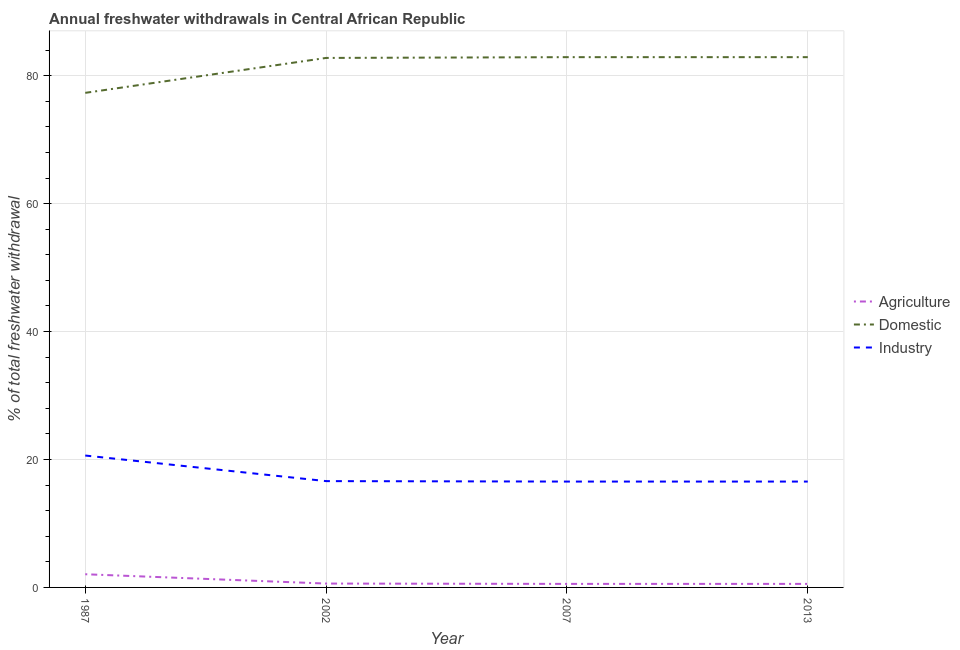How many different coloured lines are there?
Give a very brief answer. 3. Is the number of lines equal to the number of legend labels?
Your answer should be compact. Yes. What is the percentage of freshwater withdrawal for agriculture in 1987?
Your response must be concise. 2.06. Across all years, what is the maximum percentage of freshwater withdrawal for agriculture?
Make the answer very short. 2.06. Across all years, what is the minimum percentage of freshwater withdrawal for agriculture?
Make the answer very short. 0.55. What is the total percentage of freshwater withdrawal for domestic purposes in the graph?
Provide a succinct answer. 325.9. What is the difference between the percentage of freshwater withdrawal for industry in 1987 and that in 2002?
Offer a very short reply. 4. What is the difference between the percentage of freshwater withdrawal for industry in 2007 and the percentage of freshwater withdrawal for domestic purposes in 2002?
Keep it short and to the point. -66.23. What is the average percentage of freshwater withdrawal for industry per year?
Ensure brevity in your answer.  17.59. In the year 2002, what is the difference between the percentage of freshwater withdrawal for agriculture and percentage of freshwater withdrawal for industry?
Offer a terse response. -16.02. What is the ratio of the percentage of freshwater withdrawal for domestic purposes in 1987 to that in 2002?
Provide a short and direct response. 0.93. What is the difference between the highest and the second highest percentage of freshwater withdrawal for domestic purposes?
Provide a short and direct response. 0. What is the difference between the highest and the lowest percentage of freshwater withdrawal for agriculture?
Keep it short and to the point. 1.51. In how many years, is the percentage of freshwater withdrawal for domestic purposes greater than the average percentage of freshwater withdrawal for domestic purposes taken over all years?
Your response must be concise. 3. Does the percentage of freshwater withdrawal for domestic purposes monotonically increase over the years?
Your answer should be compact. No. Is the percentage of freshwater withdrawal for industry strictly less than the percentage of freshwater withdrawal for agriculture over the years?
Your answer should be compact. No. How many lines are there?
Your answer should be very brief. 3. How many years are there in the graph?
Your response must be concise. 4. Does the graph contain grids?
Offer a very short reply. Yes. Where does the legend appear in the graph?
Keep it short and to the point. Center right. How are the legend labels stacked?
Ensure brevity in your answer.  Vertical. What is the title of the graph?
Give a very brief answer. Annual freshwater withdrawals in Central African Republic. What is the label or title of the X-axis?
Give a very brief answer. Year. What is the label or title of the Y-axis?
Ensure brevity in your answer.  % of total freshwater withdrawal. What is the % of total freshwater withdrawal in Agriculture in 1987?
Ensure brevity in your answer.  2.06. What is the % of total freshwater withdrawal of Domestic in 1987?
Give a very brief answer. 77.32. What is the % of total freshwater withdrawal of Industry in 1987?
Provide a short and direct response. 20.62. What is the % of total freshwater withdrawal of Agriculture in 2002?
Give a very brief answer. 0.6. What is the % of total freshwater withdrawal of Domestic in 2002?
Your answer should be compact. 82.78. What is the % of total freshwater withdrawal of Industry in 2002?
Offer a very short reply. 16.62. What is the % of total freshwater withdrawal in Agriculture in 2007?
Offer a terse response. 0.55. What is the % of total freshwater withdrawal in Domestic in 2007?
Give a very brief answer. 82.9. What is the % of total freshwater withdrawal in Industry in 2007?
Your answer should be very brief. 16.55. What is the % of total freshwater withdrawal of Agriculture in 2013?
Offer a terse response. 0.55. What is the % of total freshwater withdrawal in Domestic in 2013?
Provide a succinct answer. 82.9. What is the % of total freshwater withdrawal in Industry in 2013?
Your answer should be compact. 16.55. Across all years, what is the maximum % of total freshwater withdrawal in Agriculture?
Offer a terse response. 2.06. Across all years, what is the maximum % of total freshwater withdrawal of Domestic?
Provide a short and direct response. 82.9. Across all years, what is the maximum % of total freshwater withdrawal of Industry?
Offer a very short reply. 20.62. Across all years, what is the minimum % of total freshwater withdrawal in Agriculture?
Give a very brief answer. 0.55. Across all years, what is the minimum % of total freshwater withdrawal of Domestic?
Provide a short and direct response. 77.32. Across all years, what is the minimum % of total freshwater withdrawal in Industry?
Your answer should be compact. 16.55. What is the total % of total freshwater withdrawal in Agriculture in the graph?
Provide a short and direct response. 3.77. What is the total % of total freshwater withdrawal of Domestic in the graph?
Provide a succinct answer. 325.9. What is the total % of total freshwater withdrawal of Industry in the graph?
Offer a very short reply. 70.34. What is the difference between the % of total freshwater withdrawal in Agriculture in 1987 and that in 2002?
Give a very brief answer. 1.46. What is the difference between the % of total freshwater withdrawal in Domestic in 1987 and that in 2002?
Your answer should be compact. -5.46. What is the difference between the % of total freshwater withdrawal of Industry in 1987 and that in 2002?
Make the answer very short. 4. What is the difference between the % of total freshwater withdrawal of Agriculture in 1987 and that in 2007?
Provide a succinct answer. 1.51. What is the difference between the % of total freshwater withdrawal in Domestic in 1987 and that in 2007?
Give a very brief answer. -5.58. What is the difference between the % of total freshwater withdrawal in Industry in 1987 and that in 2007?
Your response must be concise. 4.07. What is the difference between the % of total freshwater withdrawal of Agriculture in 1987 and that in 2013?
Your answer should be very brief. 1.51. What is the difference between the % of total freshwater withdrawal of Domestic in 1987 and that in 2013?
Keep it short and to the point. -5.58. What is the difference between the % of total freshwater withdrawal of Industry in 1987 and that in 2013?
Make the answer very short. 4.07. What is the difference between the % of total freshwater withdrawal of Agriculture in 2002 and that in 2007?
Offer a terse response. 0.05. What is the difference between the % of total freshwater withdrawal in Domestic in 2002 and that in 2007?
Ensure brevity in your answer.  -0.12. What is the difference between the % of total freshwater withdrawal in Industry in 2002 and that in 2007?
Offer a very short reply. 0.07. What is the difference between the % of total freshwater withdrawal in Agriculture in 2002 and that in 2013?
Provide a succinct answer. 0.05. What is the difference between the % of total freshwater withdrawal of Domestic in 2002 and that in 2013?
Give a very brief answer. -0.12. What is the difference between the % of total freshwater withdrawal of Industry in 2002 and that in 2013?
Make the answer very short. 0.07. What is the difference between the % of total freshwater withdrawal of Agriculture in 1987 and the % of total freshwater withdrawal of Domestic in 2002?
Your answer should be very brief. -80.72. What is the difference between the % of total freshwater withdrawal in Agriculture in 1987 and the % of total freshwater withdrawal in Industry in 2002?
Ensure brevity in your answer.  -14.56. What is the difference between the % of total freshwater withdrawal in Domestic in 1987 and the % of total freshwater withdrawal in Industry in 2002?
Your response must be concise. 60.7. What is the difference between the % of total freshwater withdrawal of Agriculture in 1987 and the % of total freshwater withdrawal of Domestic in 2007?
Your answer should be very brief. -80.84. What is the difference between the % of total freshwater withdrawal of Agriculture in 1987 and the % of total freshwater withdrawal of Industry in 2007?
Your response must be concise. -14.49. What is the difference between the % of total freshwater withdrawal of Domestic in 1987 and the % of total freshwater withdrawal of Industry in 2007?
Keep it short and to the point. 60.77. What is the difference between the % of total freshwater withdrawal in Agriculture in 1987 and the % of total freshwater withdrawal in Domestic in 2013?
Ensure brevity in your answer.  -80.84. What is the difference between the % of total freshwater withdrawal in Agriculture in 1987 and the % of total freshwater withdrawal in Industry in 2013?
Keep it short and to the point. -14.49. What is the difference between the % of total freshwater withdrawal in Domestic in 1987 and the % of total freshwater withdrawal in Industry in 2013?
Your answer should be compact. 60.77. What is the difference between the % of total freshwater withdrawal of Agriculture in 2002 and the % of total freshwater withdrawal of Domestic in 2007?
Provide a short and direct response. -82.3. What is the difference between the % of total freshwater withdrawal of Agriculture in 2002 and the % of total freshwater withdrawal of Industry in 2007?
Provide a short and direct response. -15.95. What is the difference between the % of total freshwater withdrawal of Domestic in 2002 and the % of total freshwater withdrawal of Industry in 2007?
Ensure brevity in your answer.  66.23. What is the difference between the % of total freshwater withdrawal of Agriculture in 2002 and the % of total freshwater withdrawal of Domestic in 2013?
Your response must be concise. -82.3. What is the difference between the % of total freshwater withdrawal of Agriculture in 2002 and the % of total freshwater withdrawal of Industry in 2013?
Offer a very short reply. -15.95. What is the difference between the % of total freshwater withdrawal of Domestic in 2002 and the % of total freshwater withdrawal of Industry in 2013?
Offer a very short reply. 66.23. What is the difference between the % of total freshwater withdrawal of Agriculture in 2007 and the % of total freshwater withdrawal of Domestic in 2013?
Your answer should be very brief. -82.35. What is the difference between the % of total freshwater withdrawal in Agriculture in 2007 and the % of total freshwater withdrawal in Industry in 2013?
Your response must be concise. -16. What is the difference between the % of total freshwater withdrawal in Domestic in 2007 and the % of total freshwater withdrawal in Industry in 2013?
Your answer should be very brief. 66.35. What is the average % of total freshwater withdrawal in Agriculture per year?
Ensure brevity in your answer.  0.94. What is the average % of total freshwater withdrawal in Domestic per year?
Give a very brief answer. 81.47. What is the average % of total freshwater withdrawal of Industry per year?
Ensure brevity in your answer.  17.59. In the year 1987, what is the difference between the % of total freshwater withdrawal of Agriculture and % of total freshwater withdrawal of Domestic?
Offer a very short reply. -75.26. In the year 1987, what is the difference between the % of total freshwater withdrawal of Agriculture and % of total freshwater withdrawal of Industry?
Ensure brevity in your answer.  -18.56. In the year 1987, what is the difference between the % of total freshwater withdrawal of Domestic and % of total freshwater withdrawal of Industry?
Give a very brief answer. 56.7. In the year 2002, what is the difference between the % of total freshwater withdrawal of Agriculture and % of total freshwater withdrawal of Domestic?
Make the answer very short. -82.18. In the year 2002, what is the difference between the % of total freshwater withdrawal of Agriculture and % of total freshwater withdrawal of Industry?
Make the answer very short. -16.02. In the year 2002, what is the difference between the % of total freshwater withdrawal of Domestic and % of total freshwater withdrawal of Industry?
Your answer should be compact. 66.16. In the year 2007, what is the difference between the % of total freshwater withdrawal in Agriculture and % of total freshwater withdrawal in Domestic?
Provide a succinct answer. -82.35. In the year 2007, what is the difference between the % of total freshwater withdrawal of Agriculture and % of total freshwater withdrawal of Industry?
Make the answer very short. -16. In the year 2007, what is the difference between the % of total freshwater withdrawal in Domestic and % of total freshwater withdrawal in Industry?
Offer a very short reply. 66.35. In the year 2013, what is the difference between the % of total freshwater withdrawal of Agriculture and % of total freshwater withdrawal of Domestic?
Your answer should be very brief. -82.35. In the year 2013, what is the difference between the % of total freshwater withdrawal of Agriculture and % of total freshwater withdrawal of Industry?
Offer a very short reply. -16. In the year 2013, what is the difference between the % of total freshwater withdrawal of Domestic and % of total freshwater withdrawal of Industry?
Offer a very short reply. 66.35. What is the ratio of the % of total freshwater withdrawal in Agriculture in 1987 to that in 2002?
Your answer should be compact. 3.41. What is the ratio of the % of total freshwater withdrawal in Domestic in 1987 to that in 2002?
Ensure brevity in your answer.  0.93. What is the ratio of the % of total freshwater withdrawal of Industry in 1987 to that in 2002?
Give a very brief answer. 1.24. What is the ratio of the % of total freshwater withdrawal in Agriculture in 1987 to that in 2007?
Your response must be concise. 3.74. What is the ratio of the % of total freshwater withdrawal in Domestic in 1987 to that in 2007?
Your response must be concise. 0.93. What is the ratio of the % of total freshwater withdrawal in Industry in 1987 to that in 2007?
Your answer should be very brief. 1.25. What is the ratio of the % of total freshwater withdrawal in Agriculture in 1987 to that in 2013?
Offer a very short reply. 3.74. What is the ratio of the % of total freshwater withdrawal of Domestic in 1987 to that in 2013?
Keep it short and to the point. 0.93. What is the ratio of the % of total freshwater withdrawal of Industry in 1987 to that in 2013?
Ensure brevity in your answer.  1.25. What is the ratio of the % of total freshwater withdrawal of Agriculture in 2002 to that in 2007?
Ensure brevity in your answer.  1.1. What is the ratio of the % of total freshwater withdrawal in Agriculture in 2002 to that in 2013?
Your answer should be compact. 1.1. What is the ratio of the % of total freshwater withdrawal in Domestic in 2002 to that in 2013?
Your answer should be compact. 1. What is the ratio of the % of total freshwater withdrawal of Industry in 2002 to that in 2013?
Offer a very short reply. 1. What is the ratio of the % of total freshwater withdrawal of Agriculture in 2007 to that in 2013?
Provide a short and direct response. 1. What is the ratio of the % of total freshwater withdrawal of Domestic in 2007 to that in 2013?
Make the answer very short. 1. What is the ratio of the % of total freshwater withdrawal in Industry in 2007 to that in 2013?
Provide a short and direct response. 1. What is the difference between the highest and the second highest % of total freshwater withdrawal in Agriculture?
Give a very brief answer. 1.46. What is the difference between the highest and the second highest % of total freshwater withdrawal of Domestic?
Offer a very short reply. 0. What is the difference between the highest and the second highest % of total freshwater withdrawal of Industry?
Give a very brief answer. 4. What is the difference between the highest and the lowest % of total freshwater withdrawal in Agriculture?
Offer a very short reply. 1.51. What is the difference between the highest and the lowest % of total freshwater withdrawal in Domestic?
Your answer should be very brief. 5.58. What is the difference between the highest and the lowest % of total freshwater withdrawal in Industry?
Provide a short and direct response. 4.07. 